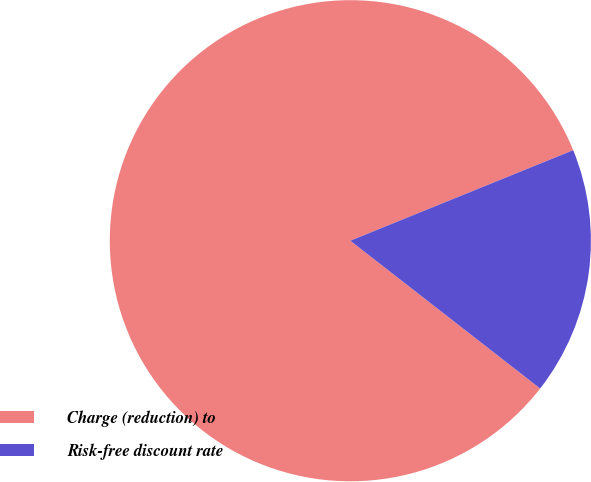Convert chart. <chart><loc_0><loc_0><loc_500><loc_500><pie_chart><fcel>Charge (reduction) to<fcel>Risk-free discount rate<nl><fcel>83.33%<fcel>16.67%<nl></chart> 